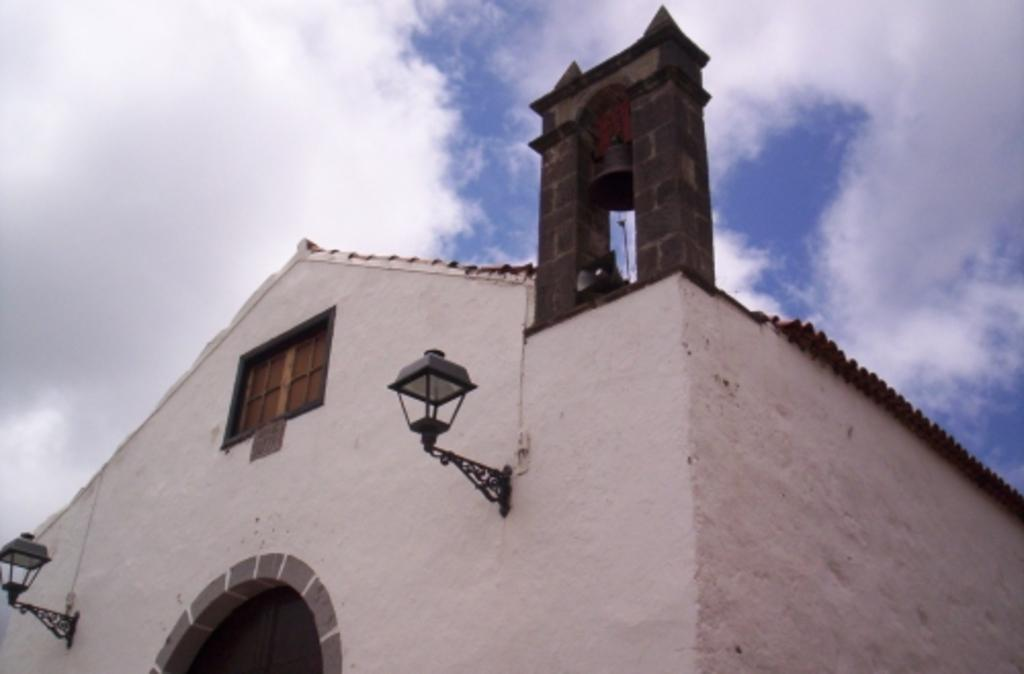What type of structure is visible in the image? There is a roof house in the image. Are there any features on the house that can be seen? Yes, there are lights on the wall of the house. What can be seen in the sky in the image? There are clouds in the sky. Can you tell me how many snakes are slithering on the roof of the house in the image? There are no snakes visible on the roof of the house in the image. What type of kitten can be seen playing with the lights on the wall of the house in the image? There is no kitten present in the image, and therefore no such activity can be observed. 